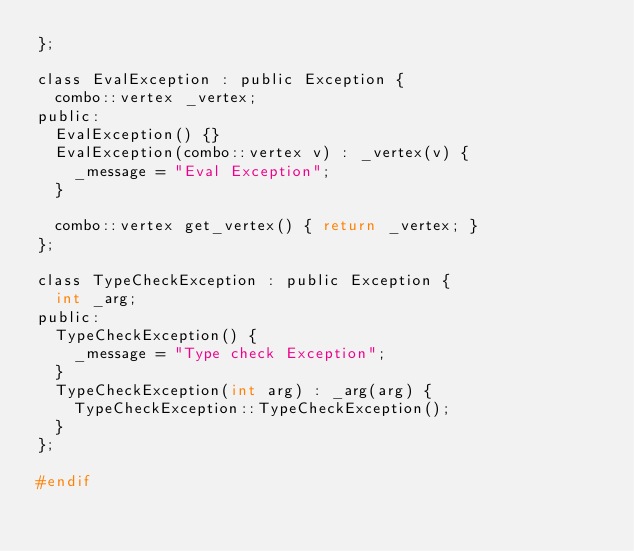<code> <loc_0><loc_0><loc_500><loc_500><_C_>};

class EvalException : public Exception {
  combo::vertex _vertex;
public:
  EvalException() {}
  EvalException(combo::vertex v) : _vertex(v) {
    _message = "Eval Exception";
  }

  combo::vertex get_vertex() { return _vertex; }
};

class TypeCheckException : public Exception {
  int _arg;
public:
  TypeCheckException() {
    _message = "Type check Exception";
  }
  TypeCheckException(int arg) : _arg(arg) {
    TypeCheckException::TypeCheckException();
  }
};

#endif
</code> 